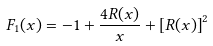<formula> <loc_0><loc_0><loc_500><loc_500>F _ { 1 } ( x ) = - 1 + \frac { 4 R ( x ) } { x } + \left [ R ( x ) \right ] ^ { 2 }</formula> 